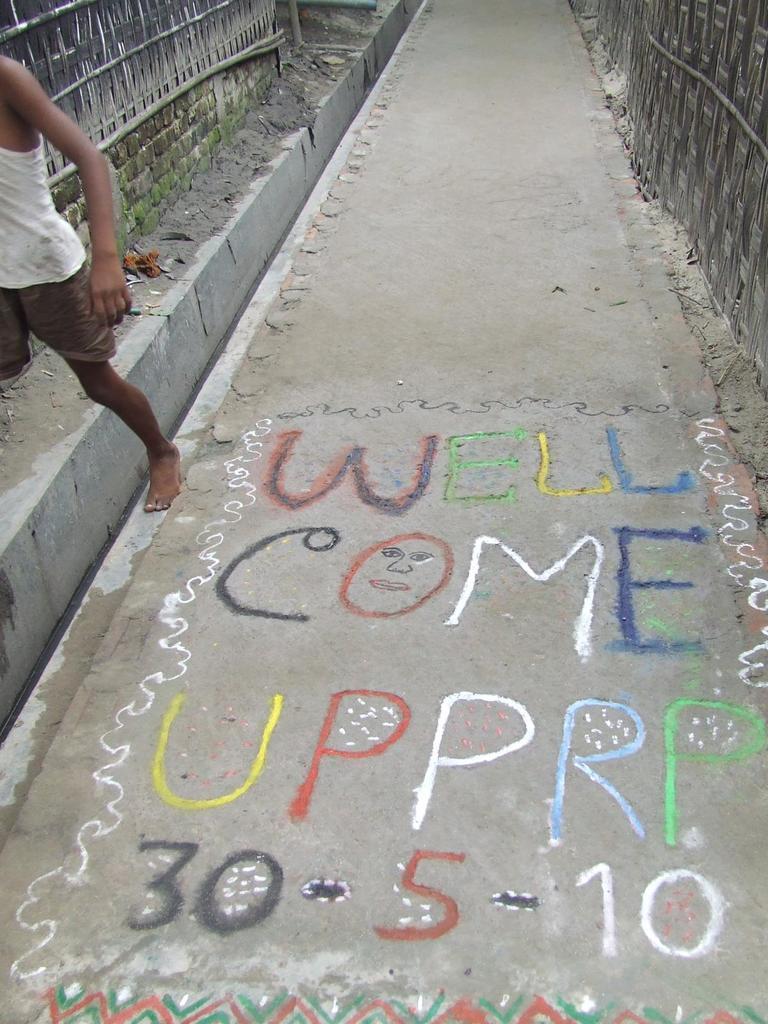Please provide a concise description of this image. On the left side of the image there is a boy. At the bottom there is a road and we can see text written on the road. In the background there is a fence. 